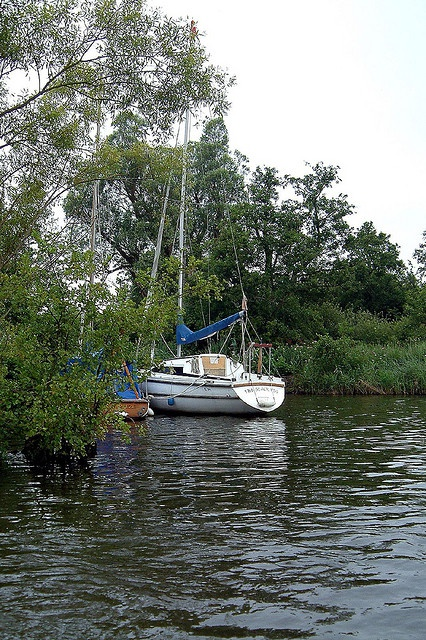Describe the objects in this image and their specific colors. I can see boat in white, black, gray, and darkgray tones and boat in white, black, brown, maroon, and gray tones in this image. 